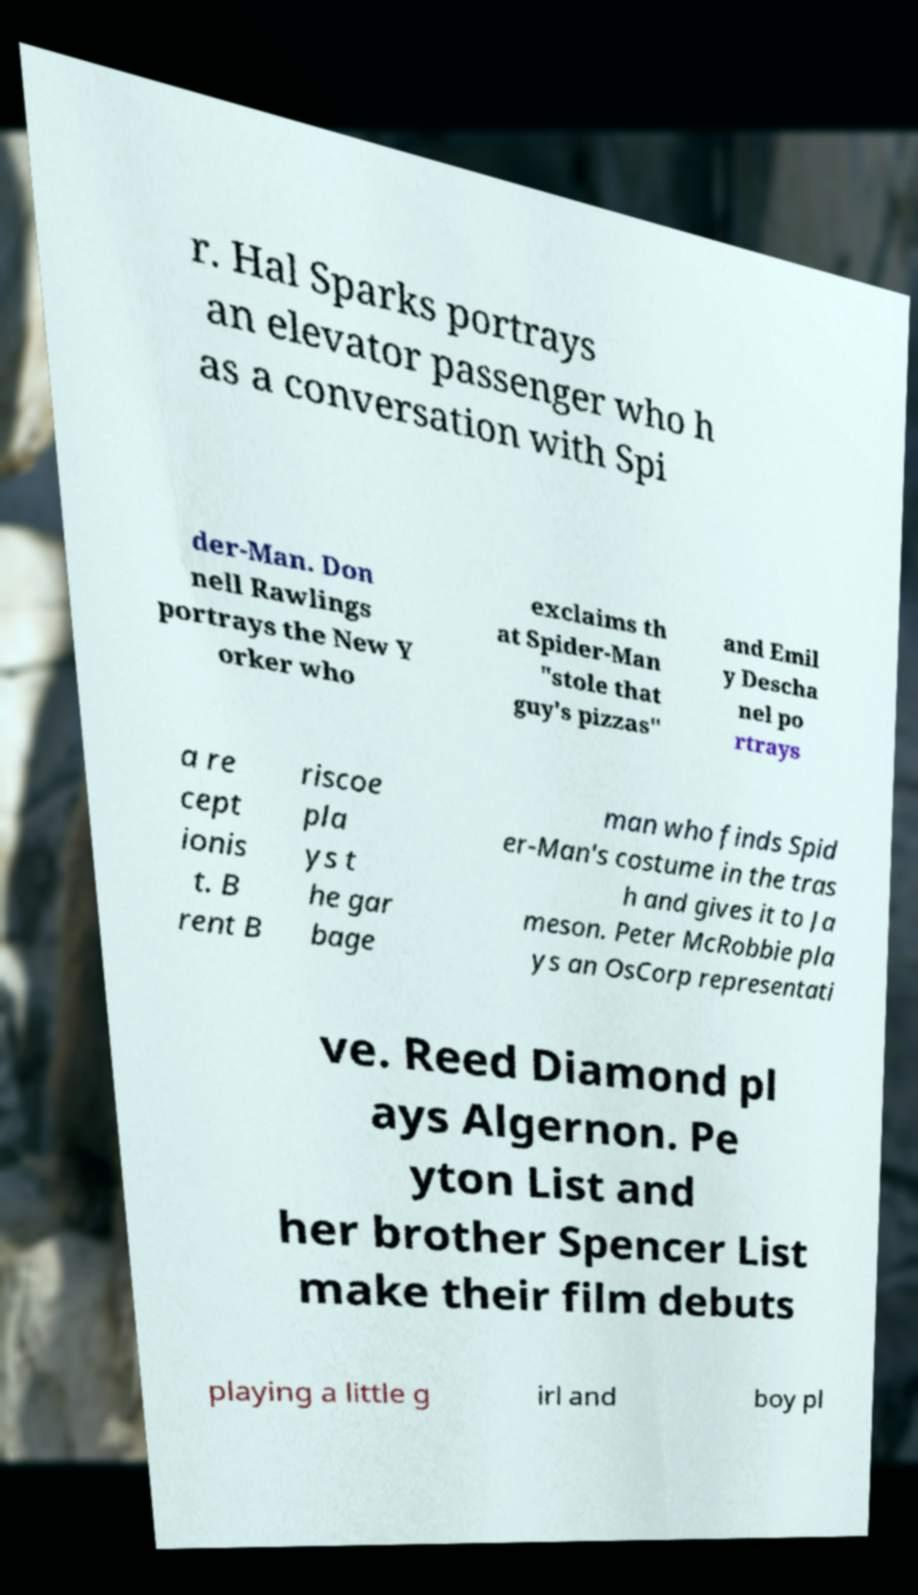Could you assist in decoding the text presented in this image and type it out clearly? r. Hal Sparks portrays an elevator passenger who h as a conversation with Spi der-Man. Don nell Rawlings portrays the New Y orker who exclaims th at Spider-Man "stole that guy's pizzas" and Emil y Descha nel po rtrays a re cept ionis t. B rent B riscoe pla ys t he gar bage man who finds Spid er-Man's costume in the tras h and gives it to Ja meson. Peter McRobbie pla ys an OsCorp representati ve. Reed Diamond pl ays Algernon. Pe yton List and her brother Spencer List make their film debuts playing a little g irl and boy pl 